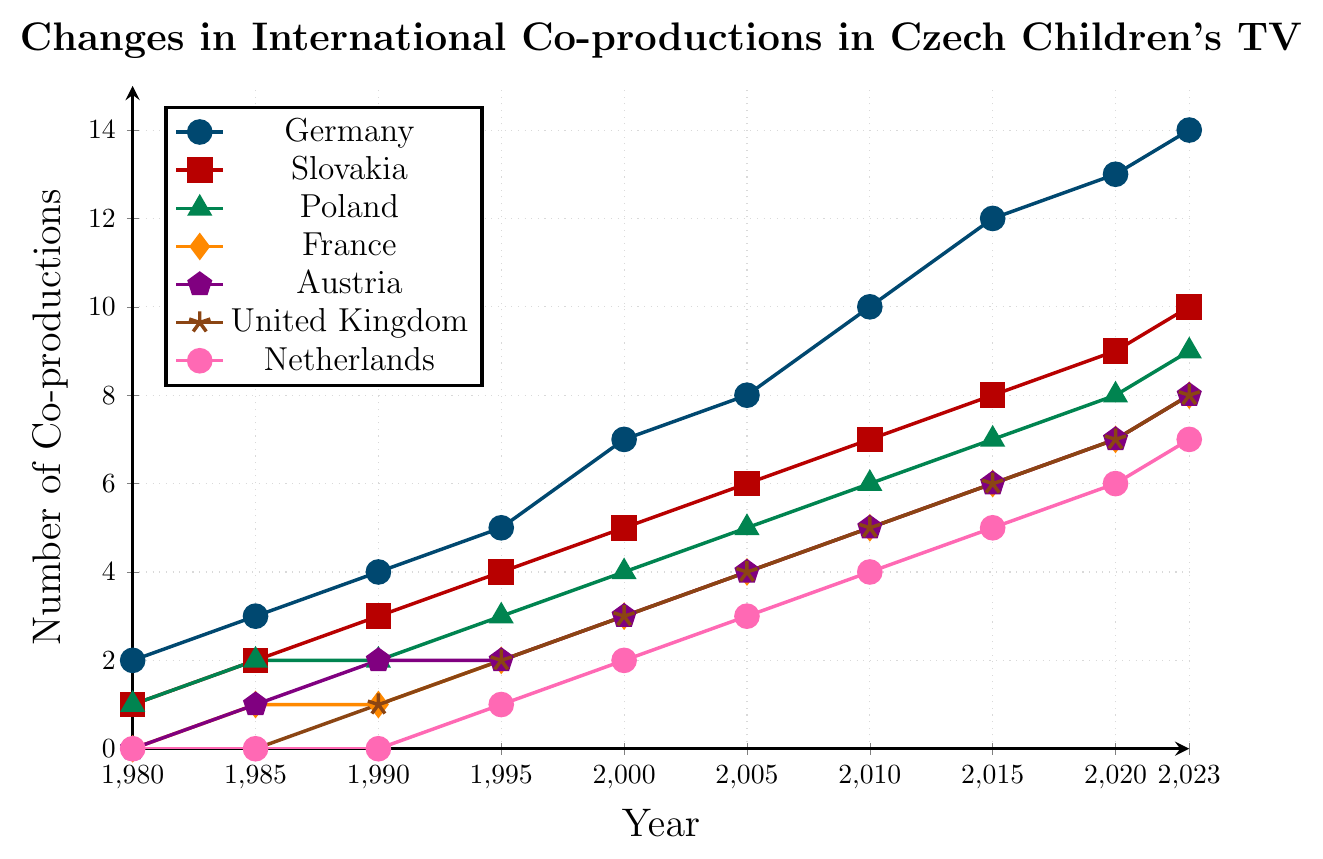Which country showed the highest increase in the number of co-productions from 1980 to 2023? To determine which country had the highest increase, we calculate the difference in the number of co-productions from 2023 and 1980 for each country: Germany (14-2=12), Slovakia (10-1=9), Poland (9-1=8), France (8-0=8), Austria (8-0=8), United Kingdom (8-0=8), Netherlands (7-0=7). The highest increase is for Germany with an increase of 12.
Answer: Germany What was the total number of co-productions with Slovakia and Poland in 2000? Sum the co-productions of Slovakia and Poland in 2000: Slovakia (5) + Poland (4) = 5 + 4 = 9.
Answer: 9 Which country has consistently had fewer co-productions compared to Germany every year? To find this, observe the number of co-productions for each country compared to Germany each year in the chart. All countries have had fewer co-productions compared to Germany every year.
Answer: All countries How many times does the Netherlands' number of co-productions increase between 1990 and 2023? The number of co-productions for Netherlands in 1990 is 0 and in 2023 is 7. The increase is 7-0 = 7.
Answer: 7 Which countries show the same number of co-productions in the year 2023? In 2023, observe the chart for the numbers of co-productions for each country: France (8), Austria (8), and United Kingdom (8) each have 8 co-productions.
Answer: France, Austria, United Kingdom Compare the number of co-productions of France and Austria in 1990 and state which has more. In 1990, look at the number of co-productions for each country: France (1) and Austria (2). Austria has more co-productions in 1990.
Answer: Austria What is the sum of co-productions from Germany and the United Kingdom in 2015? Sum the number of co-productions for Germany and the United Kingdom in 2015: Germany (12) + United Kingdom (6) = 12 + 6 = 18.
Answer: 18 Which country had the same increase in co-productions between 1985 and 1990 as it did between 1990 and 1995? For each country, compare the increase in co-productions between 1985-1990 and 1990-1995: Slovakia has the same increase (3-2=1 for 1985-1990, and 4-3=1 for 1990-1995).
Answer: Slovakia 